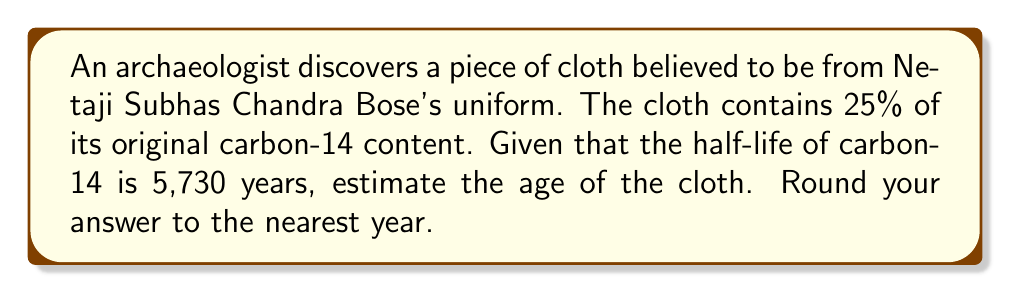Could you help me with this problem? To solve this problem, we'll use the radioactive decay equation and the given information about carbon-14 decay. Let's approach this step-by-step:

1) The radioactive decay equation is:

   $$N(t) = N_0 \cdot (1/2)^{t/t_{1/2}}$$

   Where:
   - $N(t)$ is the amount of carbon-14 remaining after time $t$
   - $N_0$ is the initial amount of carbon-14
   - $t$ is the time elapsed
   - $t_{1/2}$ is the half-life

2) We're given that 25% of the original carbon-14 remains, so:

   $$N(t)/N_0 = 0.25$$

3) Substituting this into our equation:

   $$0.25 = (1/2)^{t/5730}$$

4) Taking the natural log of both sides:

   $$\ln(0.25) = \ln((1/2)^{t/5730})$$

5) Using the logarithm property $\ln(a^b) = b\ln(a)$:

   $$\ln(0.25) = (t/5730) \cdot \ln(1/2)$$

6) Solving for $t$:

   $$t = 5730 \cdot \frac{\ln(0.25)}{\ln(1/2)}$$

7) Calculate:

   $$t = 5730 \cdot \frac{-1.3862944}{-0.6931472} \approx 11,460.45$$

8) Rounding to the nearest year:

   $$t \approx 11,460 \text{ years}$$
Answer: 11,460 years 